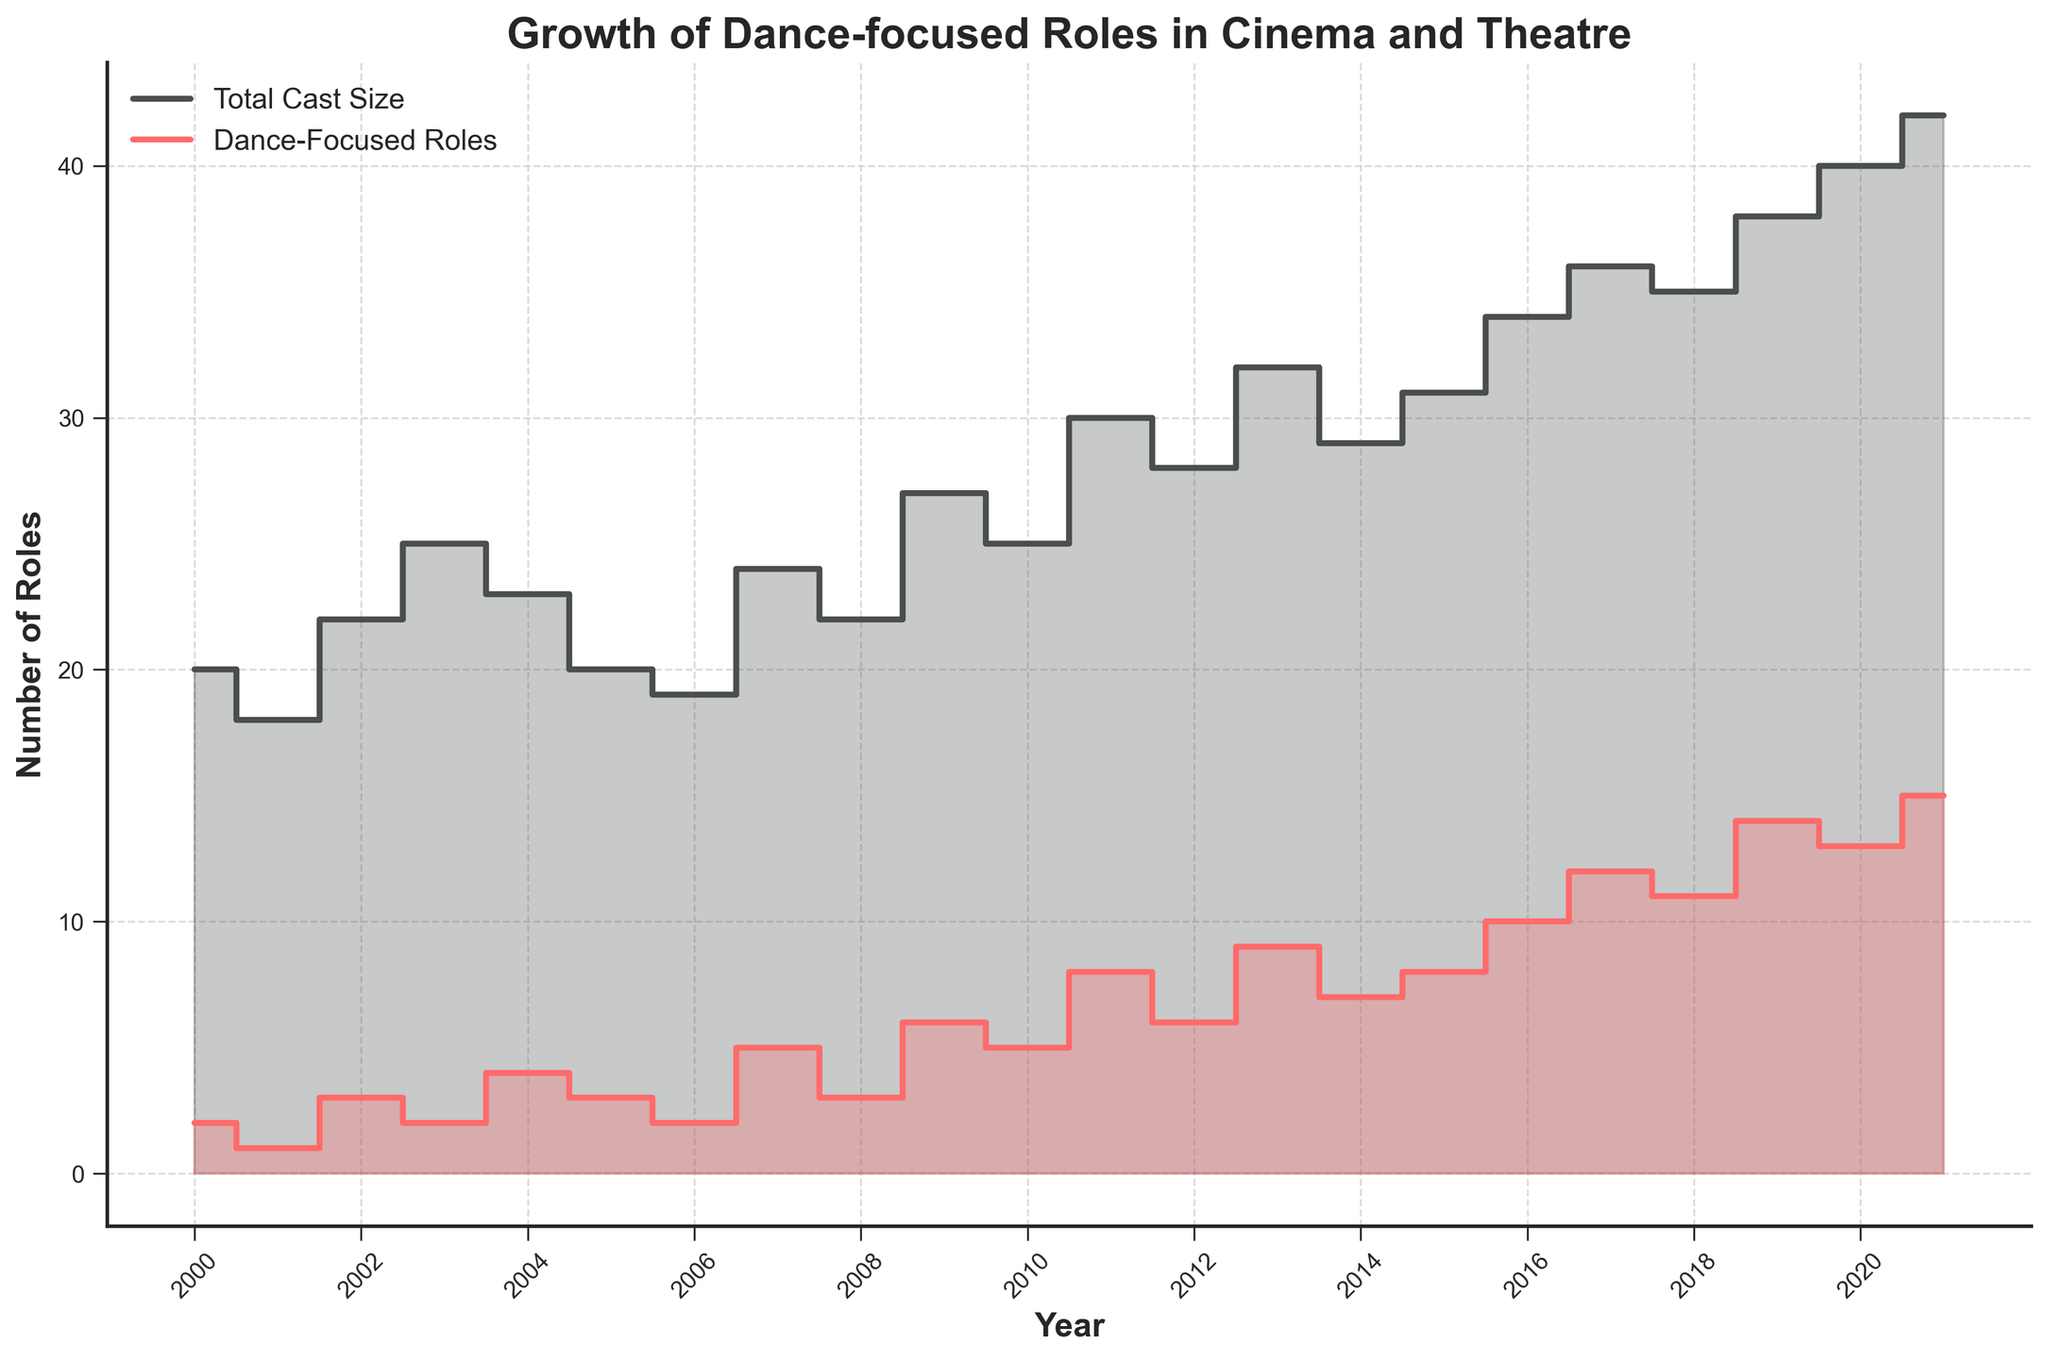what is the title of the plot? The title is written at the top of the figure. It reads "Growth of Dance-focused Roles in Cinema and Theatre".
Answer: Growth of Dance-focused Roles in Cinema and Theatre what are the colors used for the total cast size and dance-focused roles? The total cast size is represented by a darker color, and the dance-focused roles are shown in a brighter color, which are probably shades of gray and red respectively.
Answer: gray and red which year had the highest number of dance-focused roles? The plot shows the highest step for dance-focused roles in 2021.
Answer: 2021 how many data points are presented in the stair plot? By counting the number of vertical steps for either the total cast size or dance-focused roles, we observe data points for each year from 2000 to 2021, making it 22 data points.
Answer: 22 what was the difference in the number of dance-focused roles between 2018 and 2019? In 2018, there were 11 dance-focused roles, and in 2019, there were 14. The difference between them is 14 - 11.
Answer: 3 what is the label for the x-axis? The label for the x-axis is displayed along the horizontal axis, and it reads "Year".
Answer: Year which year experienced the greatest increase in dance-focused roles compared to the previous year? Observe the steps for dance-focused roles; the largest vertical distance appears between 2019 and 2020 or 2020 to 2021. By checking the plot closely, the largest increment happened from 14 (2019) to 15 (2021).
Answer: 2021 how did the total cast size change from 2016 to 2017? Looking at the steps for total cast size, the value increased from 34 in 2016 to 36 in 2017. So, the increase is 36 - 34.
Answer: 2 what is the range of years displayed in the plot? The x-axis ticks indicate the range from the minimum year 2000 to the maximum year 2021.
Answer: 2000 to 2021 